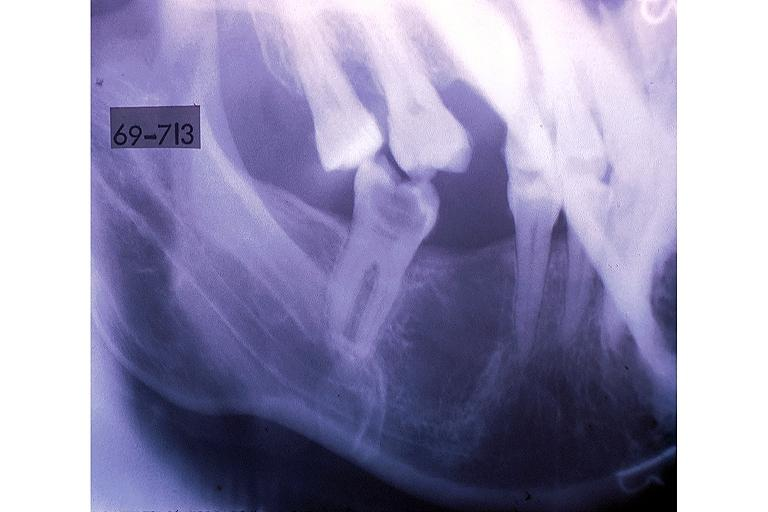does this image show hematopoietic bone marrow defect?
Answer the question using a single word or phrase. Yes 